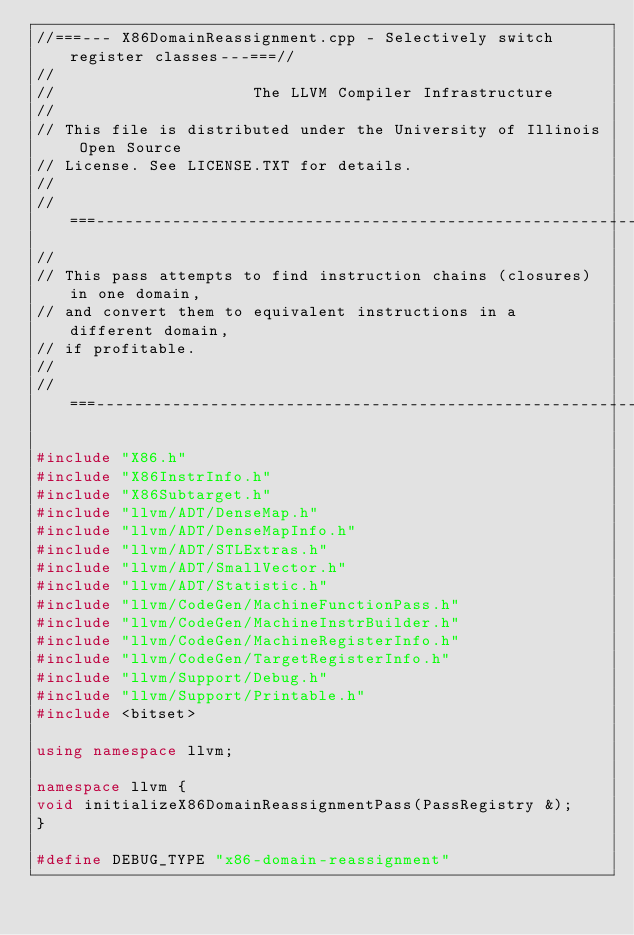Convert code to text. <code><loc_0><loc_0><loc_500><loc_500><_C++_>//===--- X86DomainReassignment.cpp - Selectively switch register classes---===//
//
//                     The LLVM Compiler Infrastructure
//
// This file is distributed under the University of Illinois Open Source
// License. See LICENSE.TXT for details.
//
//===----------------------------------------------------------------------===//
//
// This pass attempts to find instruction chains (closures) in one domain,
// and convert them to equivalent instructions in a different domain,
// if profitable.
//
//===----------------------------------------------------------------------===//

#include "X86.h"
#include "X86InstrInfo.h"
#include "X86Subtarget.h"
#include "llvm/ADT/DenseMap.h"
#include "llvm/ADT/DenseMapInfo.h"
#include "llvm/ADT/STLExtras.h"
#include "llvm/ADT/SmallVector.h"
#include "llvm/ADT/Statistic.h"
#include "llvm/CodeGen/MachineFunctionPass.h"
#include "llvm/CodeGen/MachineInstrBuilder.h"
#include "llvm/CodeGen/MachineRegisterInfo.h"
#include "llvm/CodeGen/TargetRegisterInfo.h"
#include "llvm/Support/Debug.h"
#include "llvm/Support/Printable.h"
#include <bitset>

using namespace llvm;

namespace llvm {
void initializeX86DomainReassignmentPass(PassRegistry &);
}

#define DEBUG_TYPE "x86-domain-reassignment"
</code> 